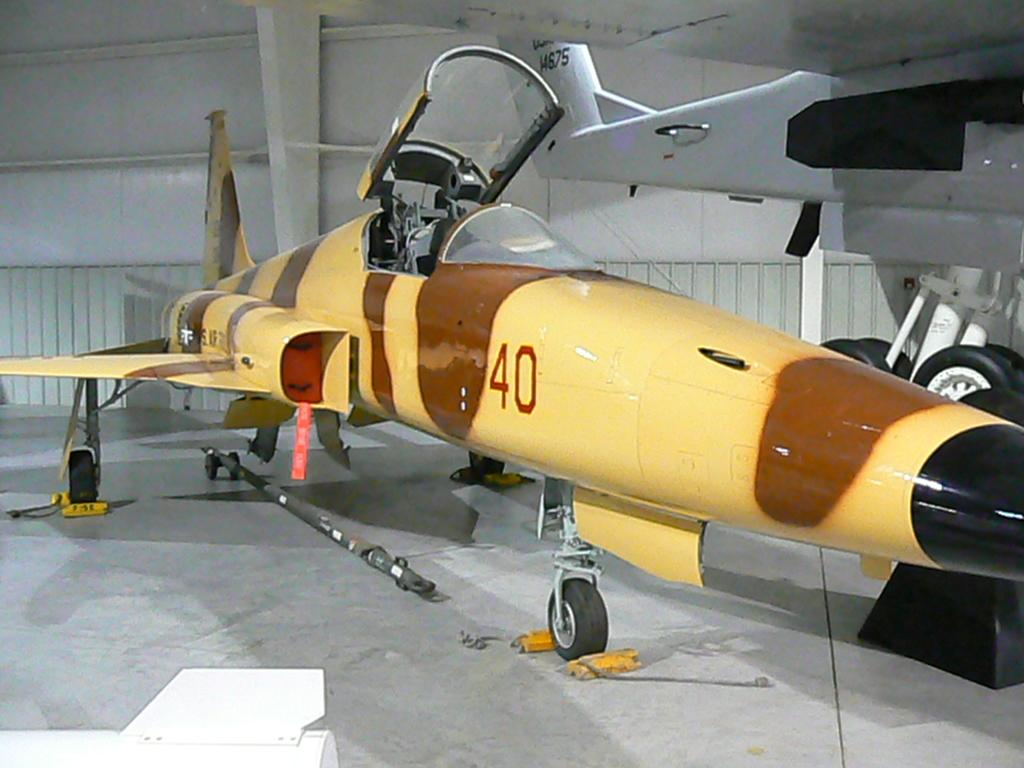<image>
Provide a brief description of the given image. A yellow fighter jet with the number 40 on it 